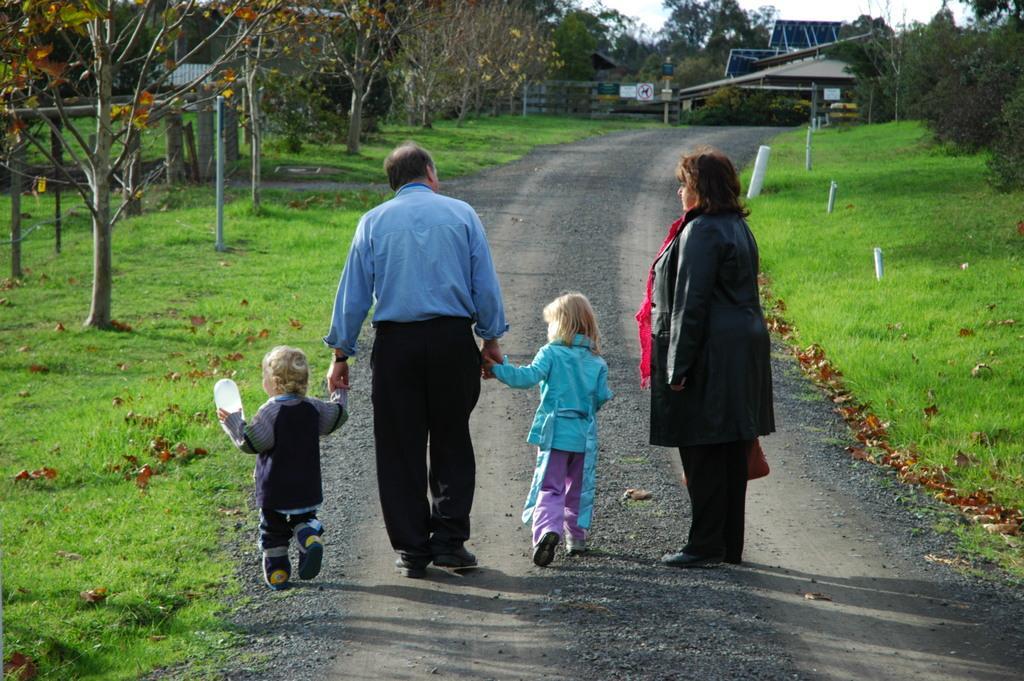Describe this image in one or two sentences. Here is the woman standing. I can see the man holding two kids and walking on the pathway. This is the grass. These are the trees. I can see the dried leaves lying on the ground. This looks like a house. I can see the sign boards attached to the pole. 